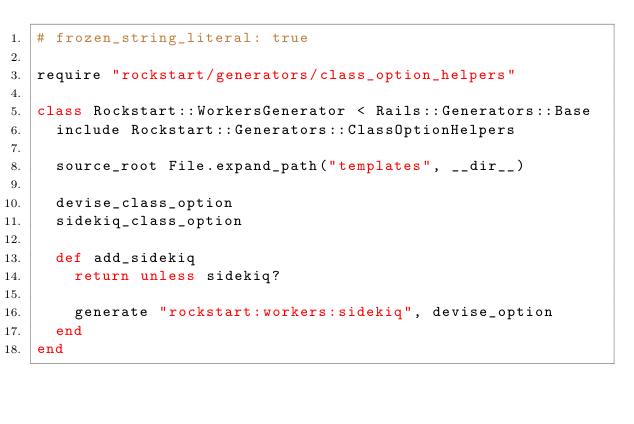Convert code to text. <code><loc_0><loc_0><loc_500><loc_500><_Ruby_># frozen_string_literal: true

require "rockstart/generators/class_option_helpers"

class Rockstart::WorkersGenerator < Rails::Generators::Base
  include Rockstart::Generators::ClassOptionHelpers

  source_root File.expand_path("templates", __dir__)

  devise_class_option
  sidekiq_class_option

  def add_sidekiq
    return unless sidekiq?

    generate "rockstart:workers:sidekiq", devise_option
  end
end
</code> 